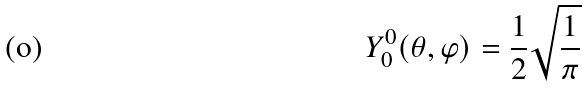<formula> <loc_0><loc_0><loc_500><loc_500>Y _ { 0 } ^ { 0 } ( \theta , \varphi ) = \frac { 1 } { 2 } \sqrt { \frac { 1 } { \pi } }</formula> 